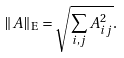<formula> <loc_0><loc_0><loc_500><loc_500>\| A \| _ { \mathrm E } = \sqrt { \sum _ { i , j } A _ { i j } ^ { 2 } } .</formula> 